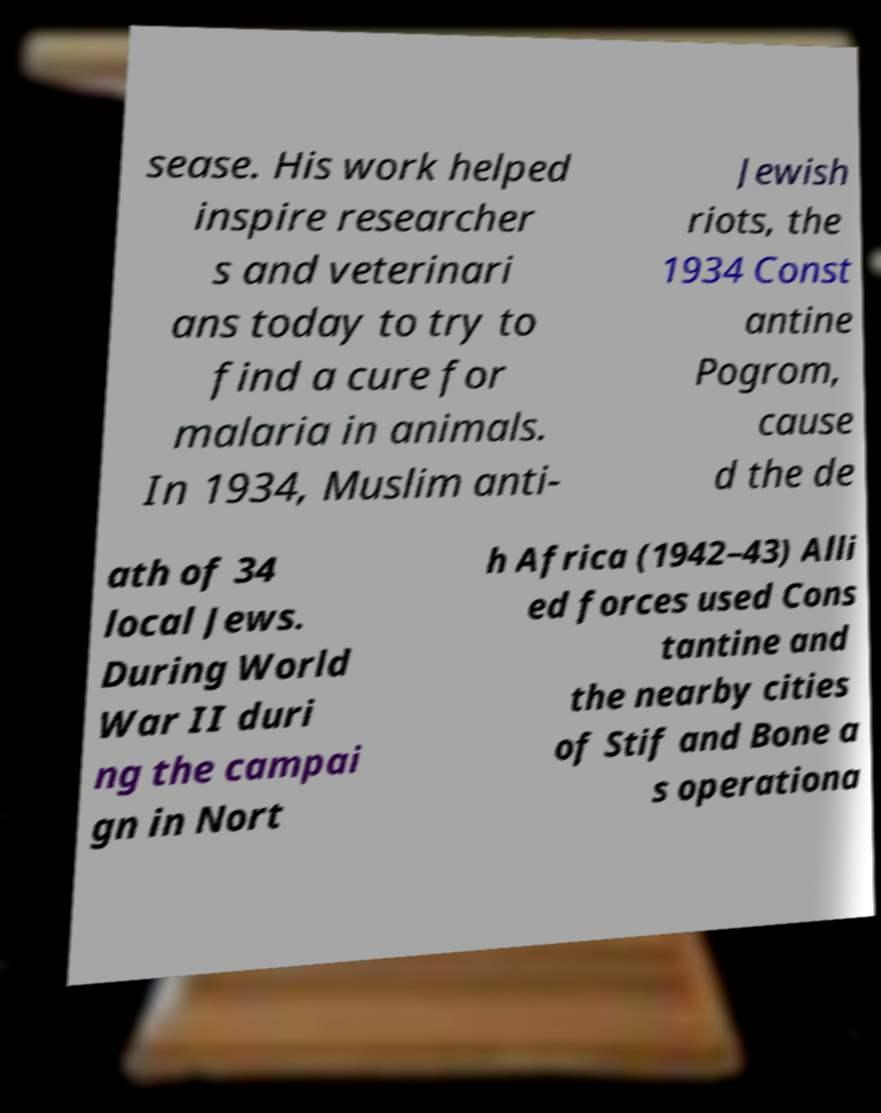Can you read and provide the text displayed in the image?This photo seems to have some interesting text. Can you extract and type it out for me? sease. His work helped inspire researcher s and veterinari ans today to try to find a cure for malaria in animals. In 1934, Muslim anti- Jewish riots, the 1934 Const antine Pogrom, cause d the de ath of 34 local Jews. During World War II duri ng the campai gn in Nort h Africa (1942–43) Alli ed forces used Cons tantine and the nearby cities of Stif and Bone a s operationa 